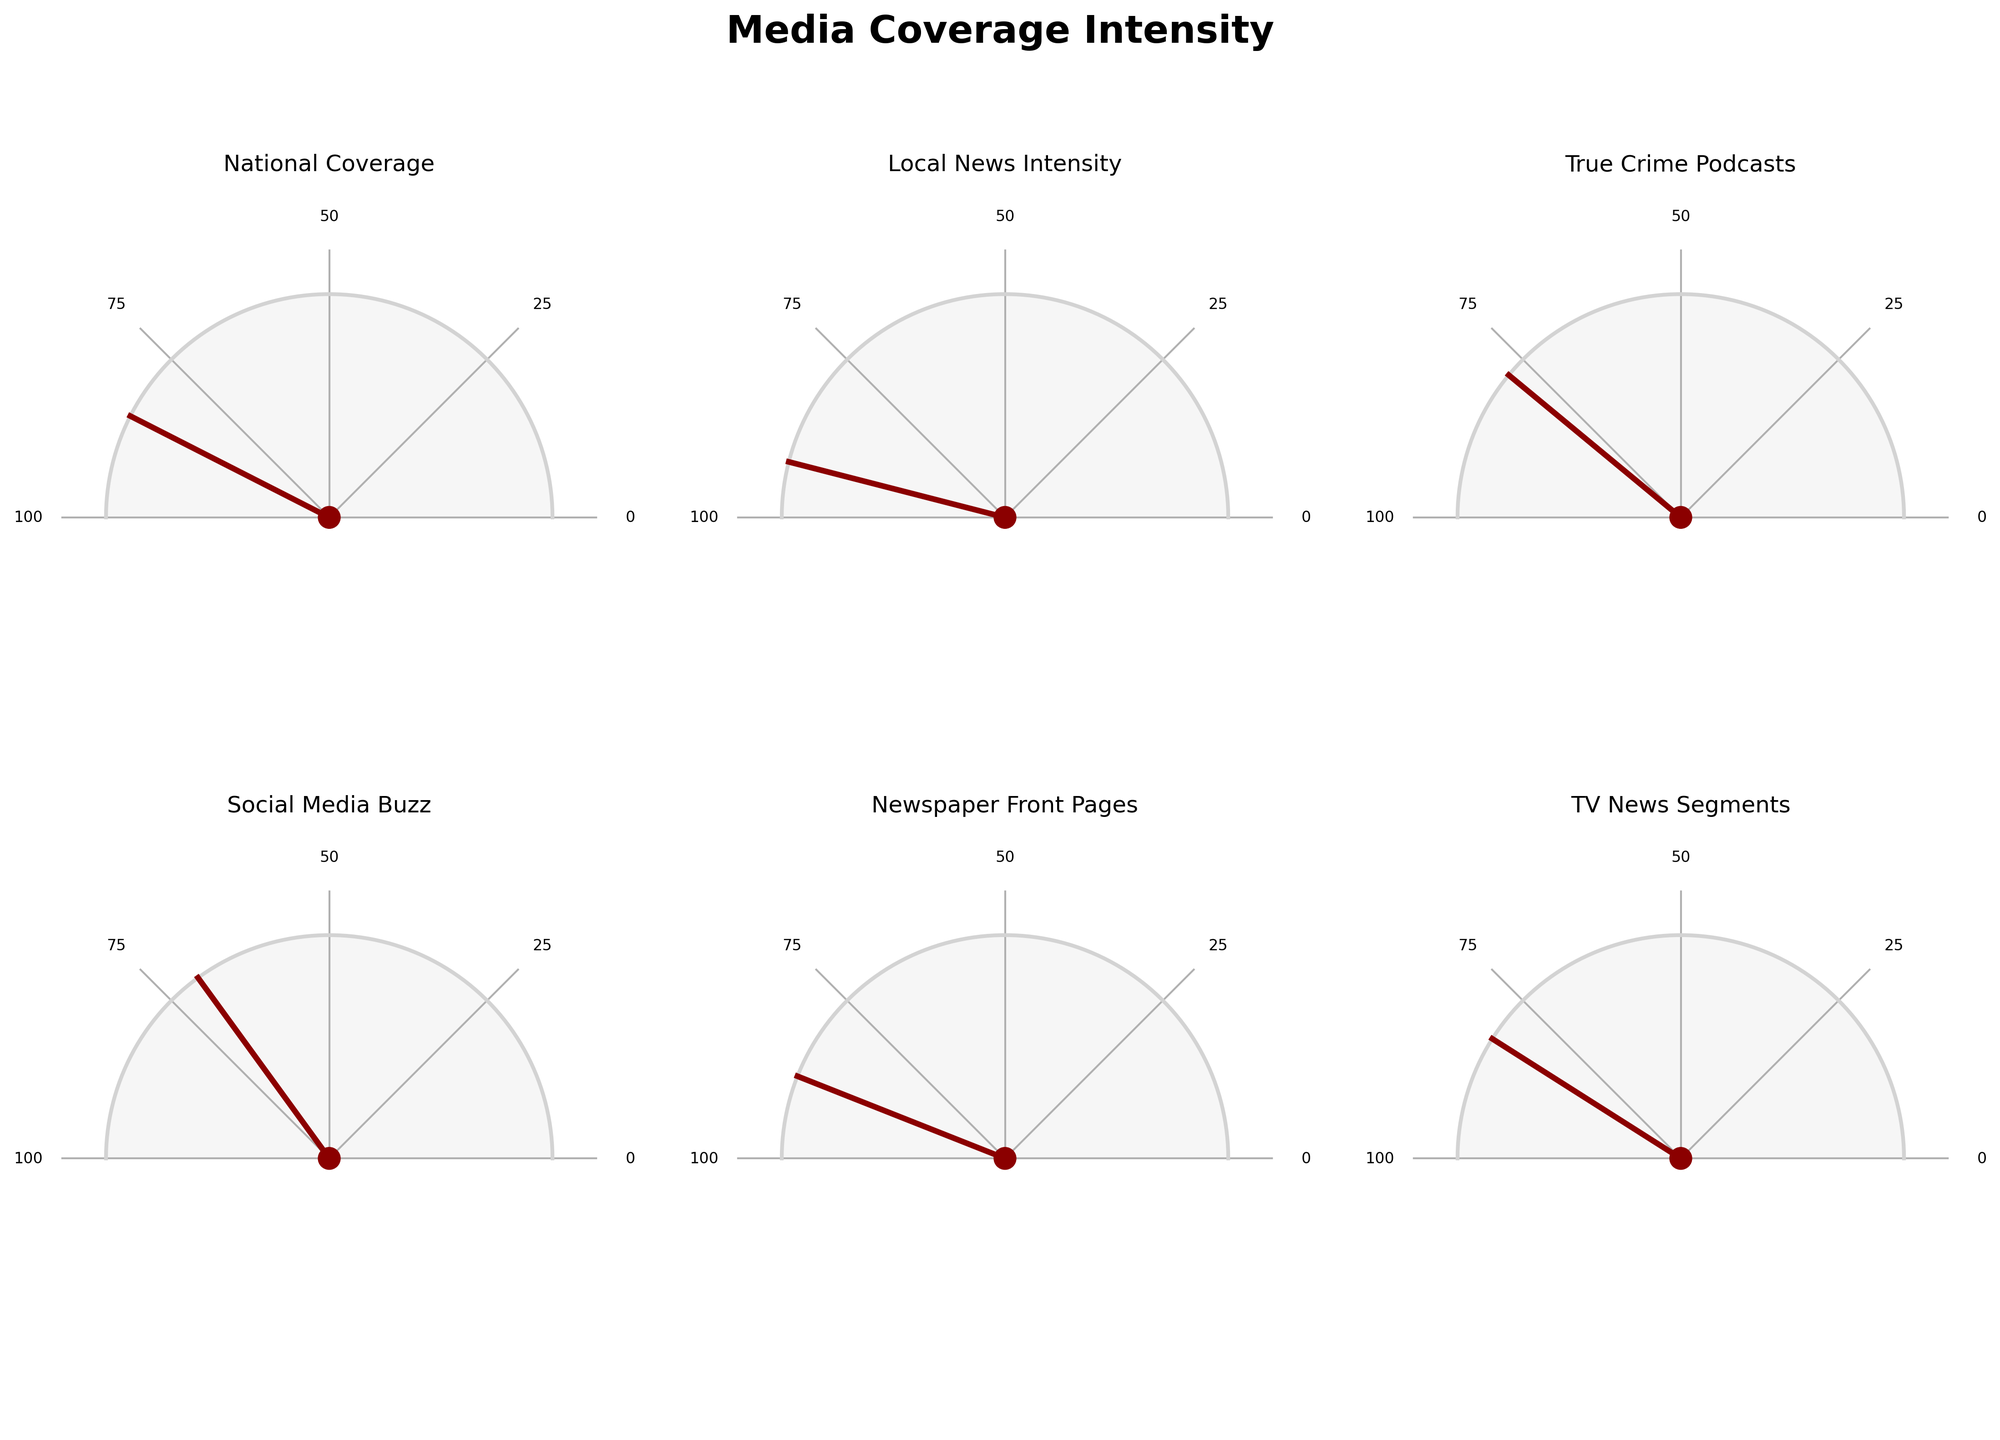What's the title of the figure? The title of the figure is displayed prominently at the top of the plot; it reads "Media Coverage Intensity."
Answer: Media Coverage Intensity Which category has the highest intensity value? By looking at the levels and their corresponding gauge charts, the category with the highest value is "Local News Intensity" at 92.
Answer: Local News Intensity What's the average intensity value across all categories? Add the values of all categories (85 + 92 + 78 + 70 + 88 + 82) to get a total of 495. Divide the total by the number of categories (6) to find the average: 495 / 6 = 82.5.
Answer: 82.5 Which two categories have the closest intensity values? By examining the values, "TV News Segments" (82) and "True Crime Podcasts" (78) have an intensity difference of only 4, which is the smallest difference among all categories.
Answer: TV News Segments and True Crime Podcasts What is the lowest intensity value in the figure? The lowest value among the categories is "Social Media Buzz" with a value of 70.
Answer: Social Media Buzz How much higher is the "Newspaper Front Pages" intensity compared to "Social Media Buzz"? The intensity of "Newspaper Front Pages" is 88 and "Social Media Buzz" is 70. The difference is calculated as 88 - 70 = 18.
Answer: 18 In how many categories is the intensity value above 80? The categories with values above 80 are "National Coverage" (85), "Local News Intensity" (92), "Newspaper Front Pages" (88), and "TV News Segments" (82), making a total of 4 categories.
Answer: 4 Is there any category where the intensity is exactly 100? By inspecting all the gauge values, no category has an intensity exactly equal to 100.
Answer: No Which category's intensity is closest to the overall average? First calculate the average (82.5). The category closest to this value is "TV News Segments" with a value of 82, which is just 0.5 less than the average.
Answer: TV News Segments Between "National Coverage" and "TV News Segments", which has a lower intensity value? Comparing the values, "National Coverage" has an intensity of 85, while "TV News Segments" has an intensity of 82. Thus, "TV News Segments" has the lower value.
Answer: TV News Segments 